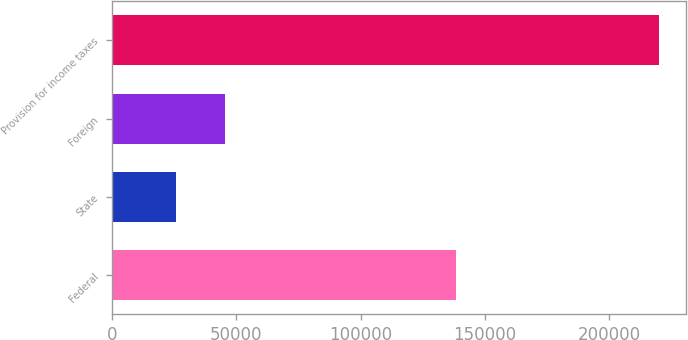<chart> <loc_0><loc_0><loc_500><loc_500><bar_chart><fcel>Federal<fcel>State<fcel>Foreign<fcel>Provision for income taxes<nl><fcel>138432<fcel>25952<fcel>45327.1<fcel>219703<nl></chart> 